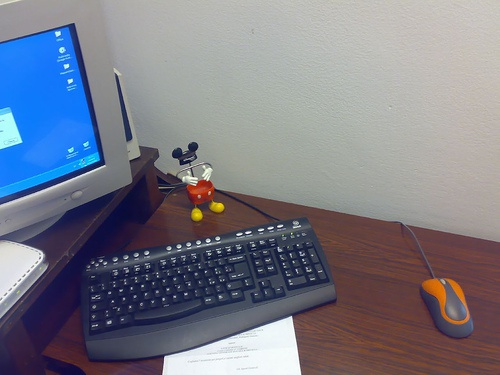Describe the objects in this image and their specific colors. I can see keyboard in lightgray, navy, gray, and darkblue tones, tv in lightgray, blue, and gray tones, and mouse in lightgray, gray, orange, navy, and red tones in this image. 